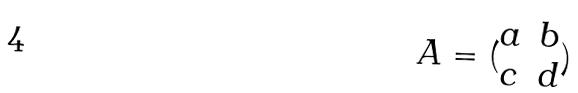<formula> <loc_0><loc_0><loc_500><loc_500>A = ( \begin{matrix} a & b \\ c & d \\ \end{matrix} )</formula> 